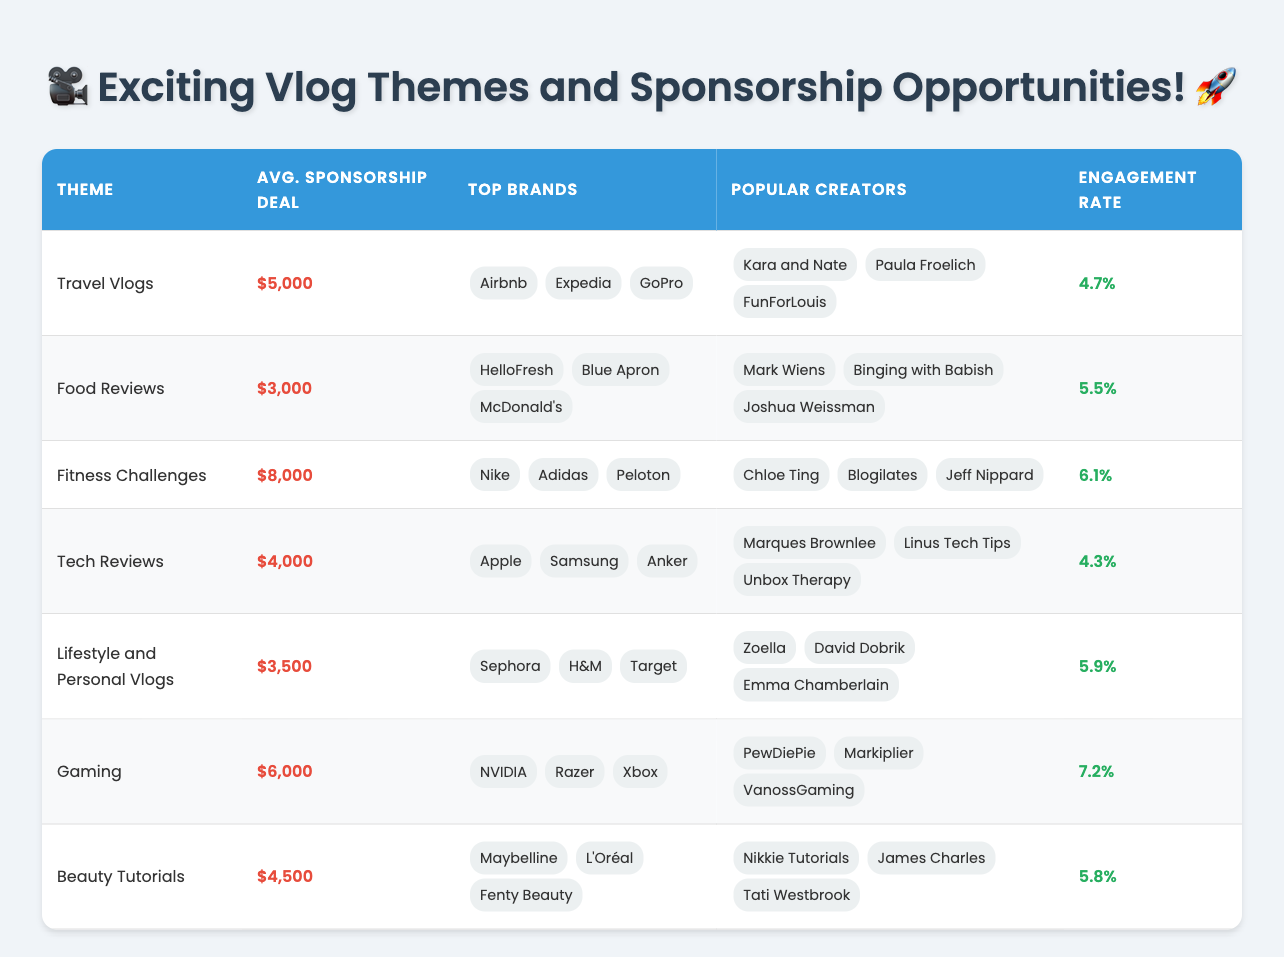What is the average sponsorship deal for Food Reviews? The average sponsorship deal for Food Reviews, as indicated in the table, is $3,000.
Answer: $3,000 Which vlog theme has the highest engagement rate? The engagement rates for each theme are 4.7% (Travel Vlogs), 5.5% (Food Reviews), 6.1% (Fitness Challenges), 4.3% (Tech Reviews), 5.9% (Lifestyle), 7.2% (Gaming), and 5.8% (Beauty Tutorials). The highest engagement rate is 7.2% for Gaming.
Answer: Gaming How many brands are associated with Fitness Challenges? The brands associated with Fitness Challenges are Nike, Adidas, and Peloton. There are a total of 3 brands listed.
Answer: 3 What is the difference in average sponsorship deals between Fitness Challenges and Tech Reviews? The average sponsorship deal for Fitness Challenges is $8,000, and for Tech Reviews, it is $4,000. The difference is calculated as $8,000 - $4,000 = $4,000.
Answer: $4,000 Is the average sponsorship deal for Travel Vlogs greater than for Food Reviews? The average sponsorship deal for Travel Vlogs is $5,000, while for Food Reviews, it is $3,000. Therefore, $5,000 is greater than $3,000.
Answer: Yes How many popular creators are listed under Lifestyle and Personal Vlogs? The table lists Zoella, David Dobrik, and Emma Chamberlain as popular creators under Lifestyle and Personal Vlogs, totaling 3 creators.
Answer: 3 What is the average engagement rate across all vlog themes? The engagement rates are: 4.7%, 5.5%, 6.1%, 4.3%, 5.9%, 7.2%, and 5.8%. Adding these rates gives a total of 39.5%. Dividing by the number of themes (7) results in an average engagement rate of 39.5% / 7 = 5.64%.
Answer: 5.64% Which vlog theme provides the lowest average sponsorship deal? The table shows the average sponsorship deals are $5,000 (Travel), $3,000 (Food), $8,000 (Fitness), $4,000 (Tech), $3,500 (Lifestyle), $6,000 (Gaming), $4,500 (Beauty). The lowest is $3,000 for Food Reviews.
Answer: Food Reviews How many popular creators are associated with Tech Reviews? Under Tech Reviews, the popular creators are Marques Brownlee, Linus Tech Tips, and Unbox Therapy, making a total of 3 creators listed.
Answer: 3 If a creator from Gaming wants to collaborate with 2 brands, what is the average sponsorship deal they can expect? The average sponsorship deal for Gaming is $6,000. Since the deal does not change with the number of brands, the expected deal remains $6,000.
Answer: $6,000 